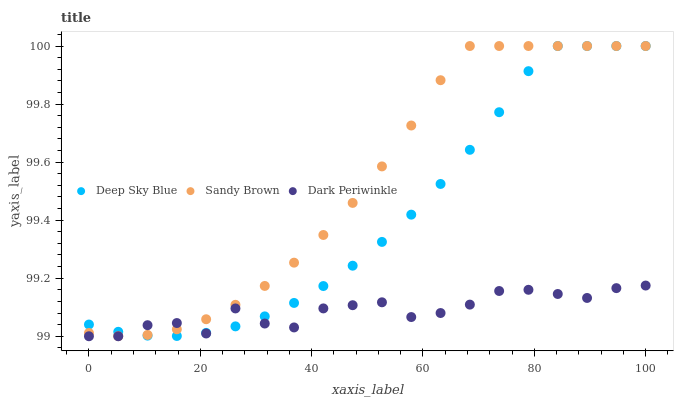Does Dark Periwinkle have the minimum area under the curve?
Answer yes or no. Yes. Does Sandy Brown have the maximum area under the curve?
Answer yes or no. Yes. Does Deep Sky Blue have the minimum area under the curve?
Answer yes or no. No. Does Deep Sky Blue have the maximum area under the curve?
Answer yes or no. No. Is Deep Sky Blue the smoothest?
Answer yes or no. Yes. Is Dark Periwinkle the roughest?
Answer yes or no. Yes. Is Dark Periwinkle the smoothest?
Answer yes or no. No. Is Deep Sky Blue the roughest?
Answer yes or no. No. Does Dark Periwinkle have the lowest value?
Answer yes or no. Yes. Does Deep Sky Blue have the lowest value?
Answer yes or no. No. Does Deep Sky Blue have the highest value?
Answer yes or no. Yes. Does Dark Periwinkle have the highest value?
Answer yes or no. No. Does Sandy Brown intersect Dark Periwinkle?
Answer yes or no. Yes. Is Sandy Brown less than Dark Periwinkle?
Answer yes or no. No. Is Sandy Brown greater than Dark Periwinkle?
Answer yes or no. No. 